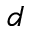<formula> <loc_0><loc_0><loc_500><loc_500>d</formula> 